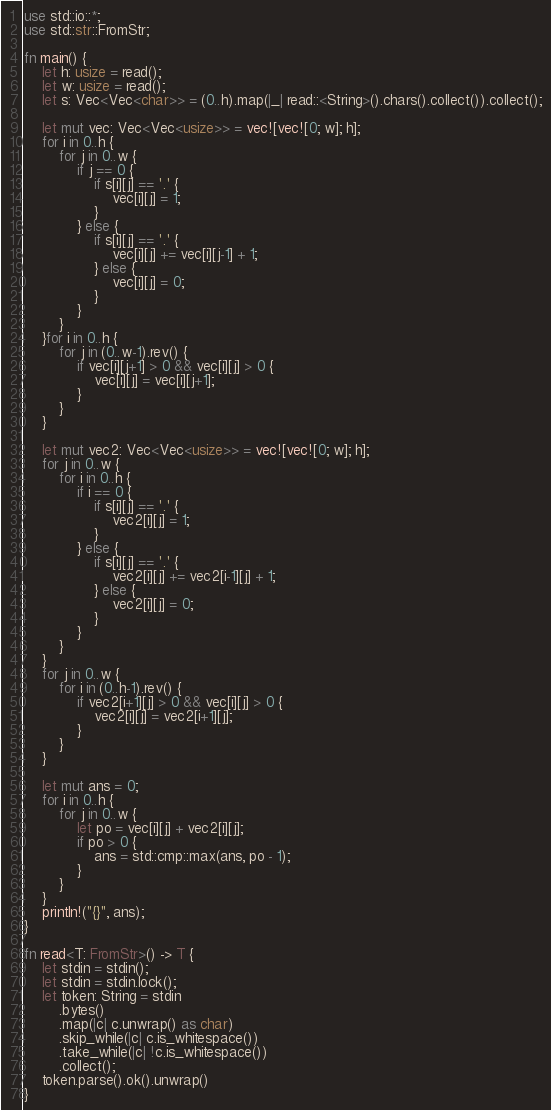<code> <loc_0><loc_0><loc_500><loc_500><_Rust_>use std::io::*;
use std::str::FromStr;

fn main() {
    let h: usize = read();
    let w: usize = read();
    let s: Vec<Vec<char>> = (0..h).map(|_| read::<String>().chars().collect()).collect();

    let mut vec: Vec<Vec<usize>> = vec![vec![0; w]; h];
    for i in 0..h {
        for j in 0..w {
            if j == 0 {
                if s[i][j] == '.' {
                    vec[i][j] = 1;
                }
            } else {
                if s[i][j] == '.' {
                    vec[i][j] += vec[i][j-1] + 1;
                } else {
                    vec[i][j] = 0;
                }
            }
        }
    }for i in 0..h {
        for j in (0..w-1).rev() {
            if vec[i][j+1] > 0 && vec[i][j] > 0 {
                vec[i][j] = vec[i][j+1];
            }
        }
    }
    
    let mut vec2: Vec<Vec<usize>> = vec![vec![0; w]; h];
    for j in 0..w {
        for i in 0..h {
            if i == 0 {
                if s[i][j] == '.' {
                    vec2[i][j] = 1;
                }
            } else {
                if s[i][j] == '.' {
                    vec2[i][j] += vec2[i-1][j] + 1;
                } else {
                    vec2[i][j] = 0;
                }
            }
        }
    }
    for j in 0..w {
        for i in (0..h-1).rev() {
            if vec2[i+1][j] > 0 && vec[i][j] > 0 {
                vec2[i][j] = vec2[i+1][j];
            }
        }
    }

    let mut ans = 0;
    for i in 0..h {
        for j in 0..w {
            let po = vec[i][j] + vec2[i][j];
            if po > 0 {
                ans = std::cmp::max(ans, po - 1);
            }
        }
    }
    println!("{}", ans);
}

fn read<T: FromStr>() -> T {
    let stdin = stdin();
    let stdin = stdin.lock();
    let token: String = stdin
        .bytes()
        .map(|c| c.unwrap() as char)
        .skip_while(|c| c.is_whitespace())
        .take_while(|c| !c.is_whitespace())
        .collect();
    token.parse().ok().unwrap()
}
</code> 